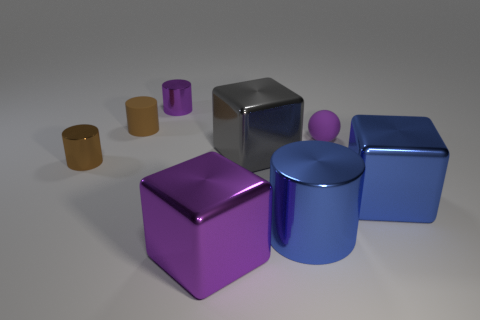Subtract all metallic cylinders. How many cylinders are left? 1 Add 1 tiny red spheres. How many objects exist? 9 Subtract all purple cubes. How many cubes are left? 2 Subtract all blocks. How many objects are left? 5 Subtract all blue cylinders. Subtract all cyan blocks. How many cylinders are left? 3 Subtract all blue spheres. How many purple cubes are left? 1 Subtract all gray things. Subtract all purple metallic things. How many objects are left? 5 Add 1 tiny rubber balls. How many tiny rubber balls are left? 2 Add 1 tiny purple things. How many tiny purple things exist? 3 Subtract 0 yellow balls. How many objects are left? 8 